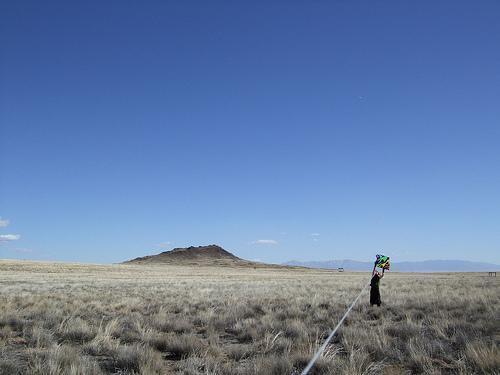How many kites are there?
Give a very brief answer. 1. 